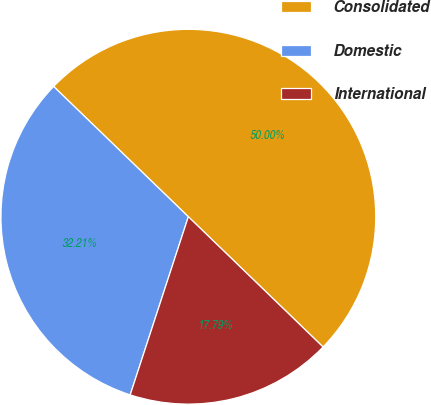Convert chart. <chart><loc_0><loc_0><loc_500><loc_500><pie_chart><fcel>Consolidated<fcel>Domestic<fcel>International<nl><fcel>50.0%<fcel>32.21%<fcel>17.79%<nl></chart> 